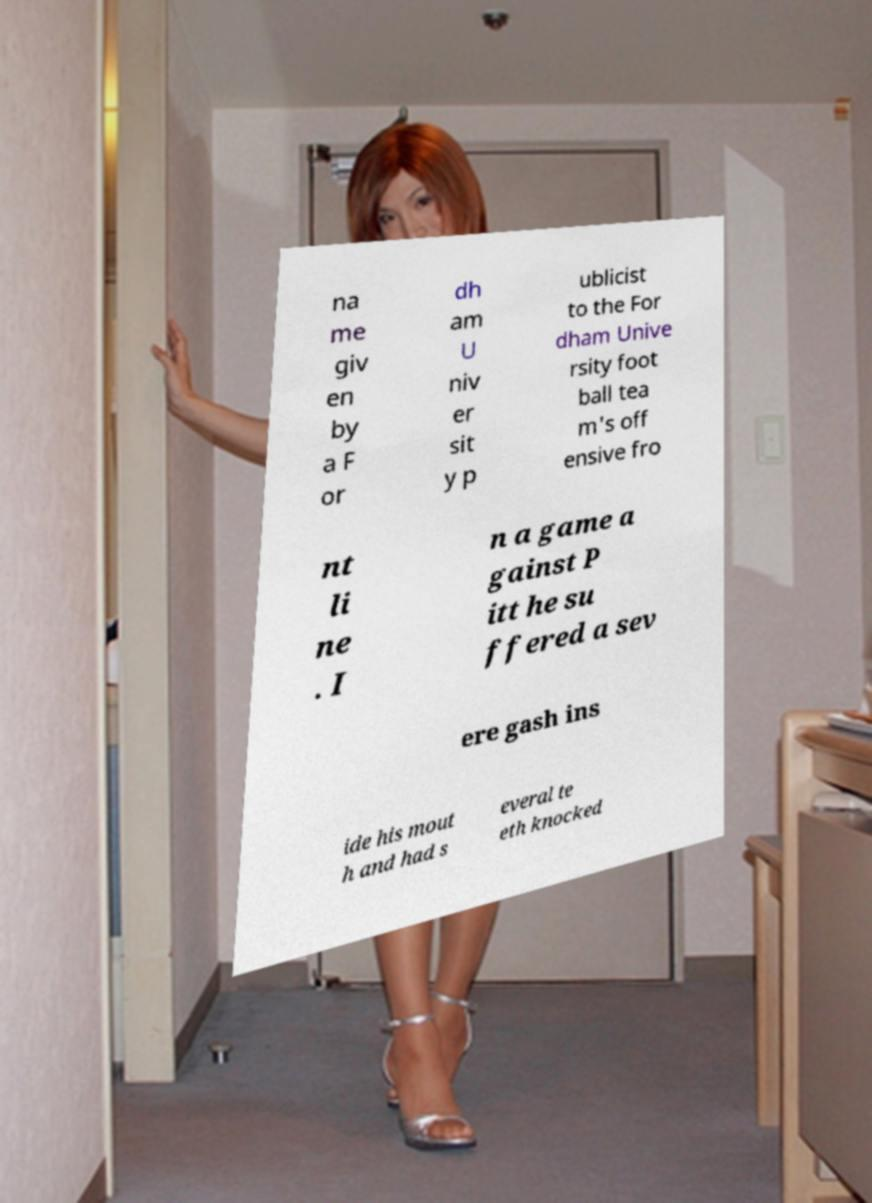I need the written content from this picture converted into text. Can you do that? na me giv en by a F or dh am U niv er sit y p ublicist to the For dham Unive rsity foot ball tea m's off ensive fro nt li ne . I n a game a gainst P itt he su ffered a sev ere gash ins ide his mout h and had s everal te eth knocked 